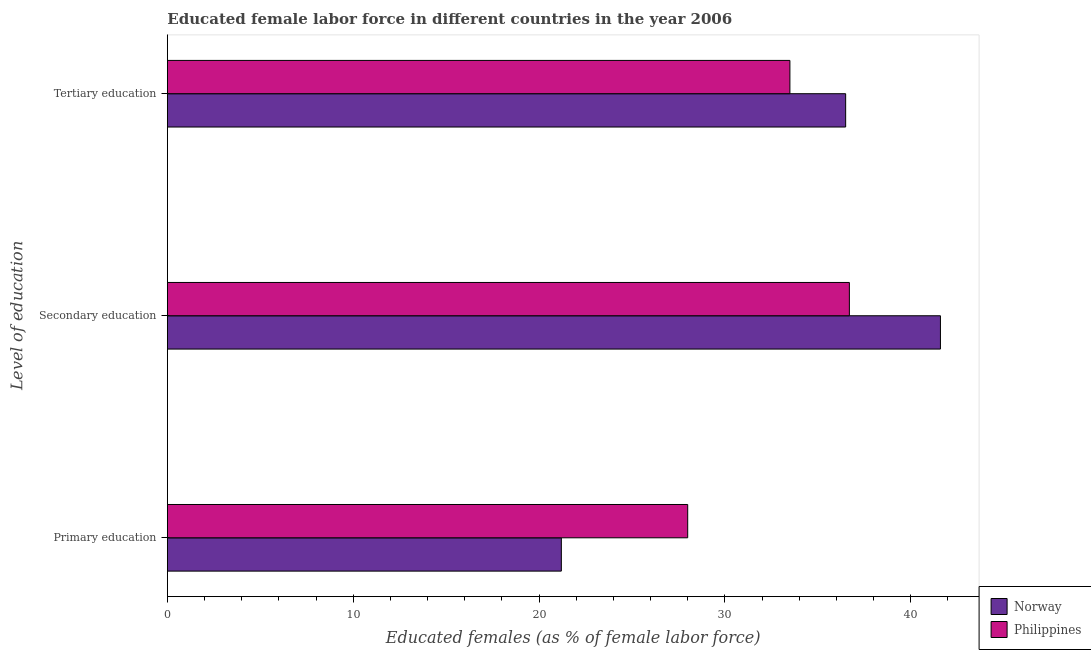How many bars are there on the 2nd tick from the bottom?
Your answer should be compact. 2. What is the label of the 3rd group of bars from the top?
Your response must be concise. Primary education. Across all countries, what is the maximum percentage of female labor force who received tertiary education?
Offer a terse response. 36.5. Across all countries, what is the minimum percentage of female labor force who received tertiary education?
Give a very brief answer. 33.5. In which country was the percentage of female labor force who received secondary education maximum?
Provide a succinct answer. Norway. What is the total percentage of female labor force who received secondary education in the graph?
Your answer should be compact. 78.3. What is the difference between the percentage of female labor force who received primary education in Philippines and that in Norway?
Provide a short and direct response. 6.8. What is the difference between the percentage of female labor force who received secondary education in Philippines and the percentage of female labor force who received tertiary education in Norway?
Make the answer very short. 0.2. What is the average percentage of female labor force who received secondary education per country?
Offer a very short reply. 39.15. In how many countries, is the percentage of female labor force who received primary education greater than 14 %?
Make the answer very short. 2. What is the ratio of the percentage of female labor force who received tertiary education in Philippines to that in Norway?
Offer a terse response. 0.92. Is the percentage of female labor force who received primary education in Philippines less than that in Norway?
Give a very brief answer. No. Is the difference between the percentage of female labor force who received tertiary education in Philippines and Norway greater than the difference between the percentage of female labor force who received primary education in Philippines and Norway?
Make the answer very short. No. What is the difference between the highest and the second highest percentage of female labor force who received primary education?
Offer a terse response. 6.8. What is the difference between the highest and the lowest percentage of female labor force who received primary education?
Offer a terse response. 6.8. What does the 2nd bar from the bottom in Primary education represents?
Your answer should be very brief. Philippines. Is it the case that in every country, the sum of the percentage of female labor force who received primary education and percentage of female labor force who received secondary education is greater than the percentage of female labor force who received tertiary education?
Provide a short and direct response. Yes. How many countries are there in the graph?
Ensure brevity in your answer.  2. Are the values on the major ticks of X-axis written in scientific E-notation?
Offer a very short reply. No. Does the graph contain grids?
Offer a terse response. No. Where does the legend appear in the graph?
Keep it short and to the point. Bottom right. How many legend labels are there?
Make the answer very short. 2. How are the legend labels stacked?
Make the answer very short. Vertical. What is the title of the graph?
Offer a very short reply. Educated female labor force in different countries in the year 2006. What is the label or title of the X-axis?
Offer a very short reply. Educated females (as % of female labor force). What is the label or title of the Y-axis?
Keep it short and to the point. Level of education. What is the Educated females (as % of female labor force) in Norway in Primary education?
Your answer should be compact. 21.2. What is the Educated females (as % of female labor force) in Norway in Secondary education?
Your answer should be very brief. 41.6. What is the Educated females (as % of female labor force) in Philippines in Secondary education?
Provide a short and direct response. 36.7. What is the Educated females (as % of female labor force) of Norway in Tertiary education?
Offer a very short reply. 36.5. What is the Educated females (as % of female labor force) of Philippines in Tertiary education?
Provide a succinct answer. 33.5. Across all Level of education, what is the maximum Educated females (as % of female labor force) of Norway?
Provide a succinct answer. 41.6. Across all Level of education, what is the maximum Educated females (as % of female labor force) in Philippines?
Your answer should be very brief. 36.7. Across all Level of education, what is the minimum Educated females (as % of female labor force) in Norway?
Offer a very short reply. 21.2. Across all Level of education, what is the minimum Educated females (as % of female labor force) in Philippines?
Provide a short and direct response. 28. What is the total Educated females (as % of female labor force) in Norway in the graph?
Your answer should be compact. 99.3. What is the total Educated females (as % of female labor force) of Philippines in the graph?
Your answer should be compact. 98.2. What is the difference between the Educated females (as % of female labor force) of Norway in Primary education and that in Secondary education?
Your answer should be very brief. -20.4. What is the difference between the Educated females (as % of female labor force) of Philippines in Primary education and that in Secondary education?
Offer a very short reply. -8.7. What is the difference between the Educated females (as % of female labor force) in Norway in Primary education and that in Tertiary education?
Your answer should be very brief. -15.3. What is the difference between the Educated females (as % of female labor force) in Philippines in Secondary education and that in Tertiary education?
Your answer should be compact. 3.2. What is the difference between the Educated females (as % of female labor force) in Norway in Primary education and the Educated females (as % of female labor force) in Philippines in Secondary education?
Offer a very short reply. -15.5. What is the average Educated females (as % of female labor force) in Norway per Level of education?
Your response must be concise. 33.1. What is the average Educated females (as % of female labor force) of Philippines per Level of education?
Keep it short and to the point. 32.73. What is the ratio of the Educated females (as % of female labor force) of Norway in Primary education to that in Secondary education?
Provide a succinct answer. 0.51. What is the ratio of the Educated females (as % of female labor force) in Philippines in Primary education to that in Secondary education?
Offer a terse response. 0.76. What is the ratio of the Educated females (as % of female labor force) of Norway in Primary education to that in Tertiary education?
Your response must be concise. 0.58. What is the ratio of the Educated females (as % of female labor force) in Philippines in Primary education to that in Tertiary education?
Ensure brevity in your answer.  0.84. What is the ratio of the Educated females (as % of female labor force) in Norway in Secondary education to that in Tertiary education?
Offer a terse response. 1.14. What is the ratio of the Educated females (as % of female labor force) in Philippines in Secondary education to that in Tertiary education?
Provide a short and direct response. 1.1. What is the difference between the highest and the second highest Educated females (as % of female labor force) of Philippines?
Your answer should be compact. 3.2. What is the difference between the highest and the lowest Educated females (as % of female labor force) in Norway?
Your answer should be very brief. 20.4. What is the difference between the highest and the lowest Educated females (as % of female labor force) of Philippines?
Your answer should be very brief. 8.7. 